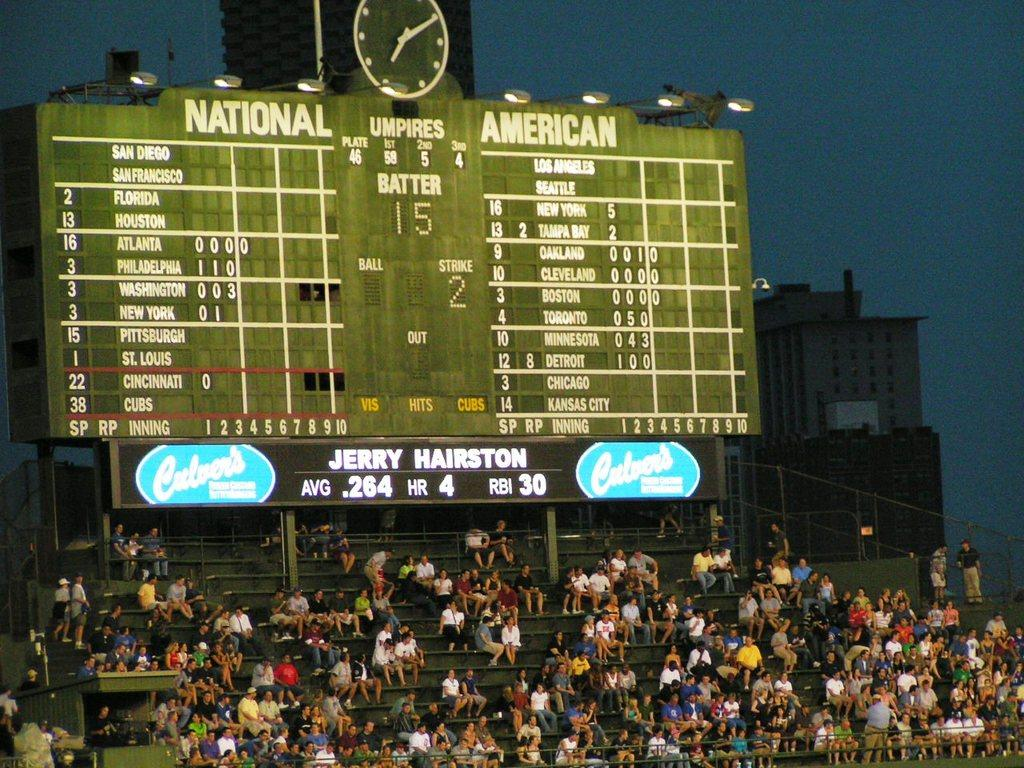<image>
Render a clear and concise summary of the photo. According to the board player Jerry Hairston is currently up to bat 